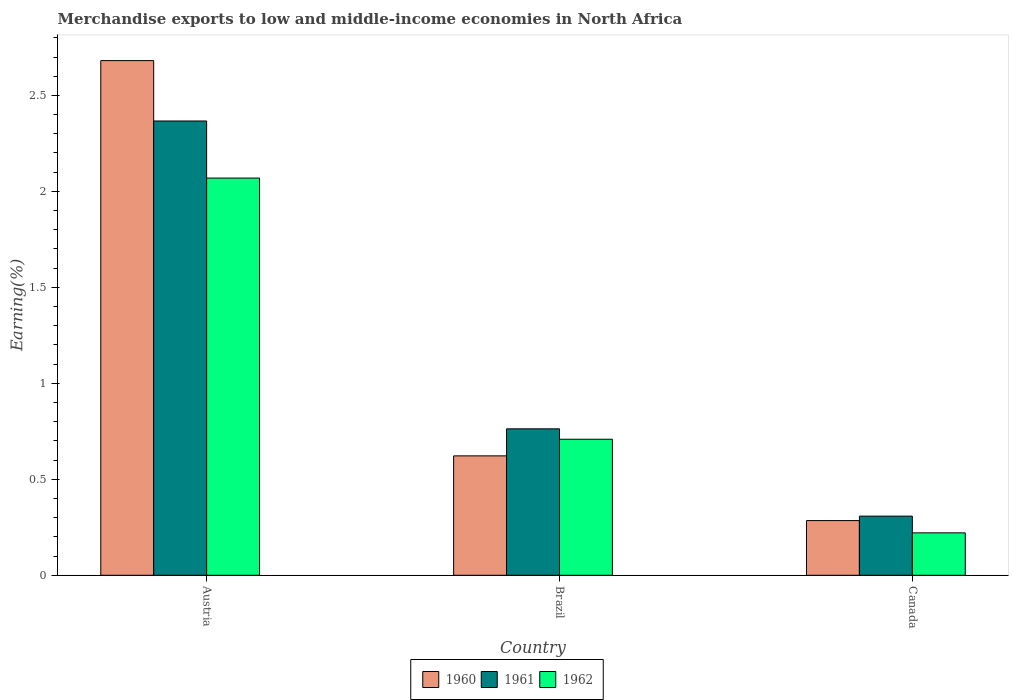How many different coloured bars are there?
Ensure brevity in your answer.  3. Are the number of bars per tick equal to the number of legend labels?
Provide a short and direct response. Yes. How many bars are there on the 2nd tick from the left?
Offer a terse response. 3. What is the percentage of amount earned from merchandise exports in 1961 in Brazil?
Make the answer very short. 0.76. Across all countries, what is the maximum percentage of amount earned from merchandise exports in 1962?
Your response must be concise. 2.07. Across all countries, what is the minimum percentage of amount earned from merchandise exports in 1962?
Offer a terse response. 0.22. In which country was the percentage of amount earned from merchandise exports in 1960 maximum?
Make the answer very short. Austria. What is the total percentage of amount earned from merchandise exports in 1962 in the graph?
Your answer should be compact. 3. What is the difference between the percentage of amount earned from merchandise exports in 1960 in Brazil and that in Canada?
Your response must be concise. 0.34. What is the difference between the percentage of amount earned from merchandise exports in 1962 in Canada and the percentage of amount earned from merchandise exports in 1961 in Austria?
Make the answer very short. -2.15. What is the average percentage of amount earned from merchandise exports in 1962 per country?
Provide a succinct answer. 1. What is the difference between the percentage of amount earned from merchandise exports of/in 1962 and percentage of amount earned from merchandise exports of/in 1960 in Brazil?
Offer a terse response. 0.09. In how many countries, is the percentage of amount earned from merchandise exports in 1962 greater than 0.4 %?
Keep it short and to the point. 2. What is the ratio of the percentage of amount earned from merchandise exports in 1961 in Austria to that in Canada?
Provide a short and direct response. 7.68. Is the difference between the percentage of amount earned from merchandise exports in 1962 in Austria and Brazil greater than the difference between the percentage of amount earned from merchandise exports in 1960 in Austria and Brazil?
Provide a short and direct response. No. What is the difference between the highest and the second highest percentage of amount earned from merchandise exports in 1960?
Provide a short and direct response. -2.06. What is the difference between the highest and the lowest percentage of amount earned from merchandise exports in 1961?
Your response must be concise. 2.06. In how many countries, is the percentage of amount earned from merchandise exports in 1960 greater than the average percentage of amount earned from merchandise exports in 1960 taken over all countries?
Your response must be concise. 1. What does the 3rd bar from the right in Canada represents?
Offer a very short reply. 1960. Is it the case that in every country, the sum of the percentage of amount earned from merchandise exports in 1962 and percentage of amount earned from merchandise exports in 1960 is greater than the percentage of amount earned from merchandise exports in 1961?
Offer a very short reply. Yes. Are all the bars in the graph horizontal?
Ensure brevity in your answer.  No. Are the values on the major ticks of Y-axis written in scientific E-notation?
Your response must be concise. No. Does the graph contain any zero values?
Provide a succinct answer. No. Does the graph contain grids?
Keep it short and to the point. No. What is the title of the graph?
Give a very brief answer. Merchandise exports to low and middle-income economies in North Africa. What is the label or title of the X-axis?
Give a very brief answer. Country. What is the label or title of the Y-axis?
Provide a succinct answer. Earning(%). What is the Earning(%) of 1960 in Austria?
Your answer should be compact. 2.68. What is the Earning(%) in 1961 in Austria?
Your response must be concise. 2.37. What is the Earning(%) of 1962 in Austria?
Your answer should be compact. 2.07. What is the Earning(%) in 1960 in Brazil?
Provide a short and direct response. 0.62. What is the Earning(%) of 1961 in Brazil?
Your answer should be very brief. 0.76. What is the Earning(%) of 1962 in Brazil?
Make the answer very short. 0.71. What is the Earning(%) in 1960 in Canada?
Provide a short and direct response. 0.28. What is the Earning(%) in 1961 in Canada?
Give a very brief answer. 0.31. What is the Earning(%) of 1962 in Canada?
Offer a very short reply. 0.22. Across all countries, what is the maximum Earning(%) in 1960?
Give a very brief answer. 2.68. Across all countries, what is the maximum Earning(%) in 1961?
Give a very brief answer. 2.37. Across all countries, what is the maximum Earning(%) in 1962?
Ensure brevity in your answer.  2.07. Across all countries, what is the minimum Earning(%) of 1960?
Your response must be concise. 0.28. Across all countries, what is the minimum Earning(%) in 1961?
Make the answer very short. 0.31. Across all countries, what is the minimum Earning(%) in 1962?
Make the answer very short. 0.22. What is the total Earning(%) of 1960 in the graph?
Make the answer very short. 3.59. What is the total Earning(%) in 1961 in the graph?
Offer a very short reply. 3.44. What is the total Earning(%) of 1962 in the graph?
Provide a short and direct response. 3. What is the difference between the Earning(%) of 1960 in Austria and that in Brazil?
Your answer should be very brief. 2.06. What is the difference between the Earning(%) of 1961 in Austria and that in Brazil?
Offer a terse response. 1.6. What is the difference between the Earning(%) in 1962 in Austria and that in Brazil?
Your answer should be compact. 1.36. What is the difference between the Earning(%) of 1960 in Austria and that in Canada?
Your response must be concise. 2.4. What is the difference between the Earning(%) in 1961 in Austria and that in Canada?
Provide a succinct answer. 2.06. What is the difference between the Earning(%) in 1962 in Austria and that in Canada?
Offer a terse response. 1.85. What is the difference between the Earning(%) in 1960 in Brazil and that in Canada?
Provide a short and direct response. 0.34. What is the difference between the Earning(%) of 1961 in Brazil and that in Canada?
Keep it short and to the point. 0.45. What is the difference between the Earning(%) of 1962 in Brazil and that in Canada?
Keep it short and to the point. 0.49. What is the difference between the Earning(%) of 1960 in Austria and the Earning(%) of 1961 in Brazil?
Provide a succinct answer. 1.92. What is the difference between the Earning(%) of 1960 in Austria and the Earning(%) of 1962 in Brazil?
Keep it short and to the point. 1.97. What is the difference between the Earning(%) in 1961 in Austria and the Earning(%) in 1962 in Brazil?
Ensure brevity in your answer.  1.66. What is the difference between the Earning(%) of 1960 in Austria and the Earning(%) of 1961 in Canada?
Make the answer very short. 2.37. What is the difference between the Earning(%) in 1960 in Austria and the Earning(%) in 1962 in Canada?
Give a very brief answer. 2.46. What is the difference between the Earning(%) in 1961 in Austria and the Earning(%) in 1962 in Canada?
Your answer should be compact. 2.15. What is the difference between the Earning(%) of 1960 in Brazil and the Earning(%) of 1961 in Canada?
Your answer should be compact. 0.31. What is the difference between the Earning(%) of 1960 in Brazil and the Earning(%) of 1962 in Canada?
Provide a succinct answer. 0.4. What is the difference between the Earning(%) in 1961 in Brazil and the Earning(%) in 1962 in Canada?
Your answer should be compact. 0.54. What is the average Earning(%) in 1960 per country?
Your answer should be compact. 1.2. What is the average Earning(%) in 1961 per country?
Make the answer very short. 1.15. What is the average Earning(%) in 1962 per country?
Provide a succinct answer. 1. What is the difference between the Earning(%) in 1960 and Earning(%) in 1961 in Austria?
Provide a short and direct response. 0.31. What is the difference between the Earning(%) of 1960 and Earning(%) of 1962 in Austria?
Your answer should be compact. 0.61. What is the difference between the Earning(%) of 1961 and Earning(%) of 1962 in Austria?
Your response must be concise. 0.3. What is the difference between the Earning(%) in 1960 and Earning(%) in 1961 in Brazil?
Keep it short and to the point. -0.14. What is the difference between the Earning(%) in 1960 and Earning(%) in 1962 in Brazil?
Offer a terse response. -0.09. What is the difference between the Earning(%) of 1961 and Earning(%) of 1962 in Brazil?
Your answer should be very brief. 0.05. What is the difference between the Earning(%) of 1960 and Earning(%) of 1961 in Canada?
Offer a terse response. -0.02. What is the difference between the Earning(%) of 1960 and Earning(%) of 1962 in Canada?
Your answer should be very brief. 0.06. What is the difference between the Earning(%) of 1961 and Earning(%) of 1962 in Canada?
Give a very brief answer. 0.09. What is the ratio of the Earning(%) in 1960 in Austria to that in Brazil?
Your response must be concise. 4.31. What is the ratio of the Earning(%) of 1961 in Austria to that in Brazil?
Your answer should be very brief. 3.1. What is the ratio of the Earning(%) of 1962 in Austria to that in Brazil?
Your response must be concise. 2.92. What is the ratio of the Earning(%) in 1960 in Austria to that in Canada?
Your answer should be compact. 9.41. What is the ratio of the Earning(%) in 1961 in Austria to that in Canada?
Give a very brief answer. 7.68. What is the ratio of the Earning(%) in 1962 in Austria to that in Canada?
Your answer should be compact. 9.36. What is the ratio of the Earning(%) of 1960 in Brazil to that in Canada?
Give a very brief answer. 2.18. What is the ratio of the Earning(%) in 1961 in Brazil to that in Canada?
Ensure brevity in your answer.  2.48. What is the ratio of the Earning(%) in 1962 in Brazil to that in Canada?
Your response must be concise. 3.21. What is the difference between the highest and the second highest Earning(%) of 1960?
Provide a short and direct response. 2.06. What is the difference between the highest and the second highest Earning(%) of 1961?
Provide a succinct answer. 1.6. What is the difference between the highest and the second highest Earning(%) of 1962?
Your answer should be very brief. 1.36. What is the difference between the highest and the lowest Earning(%) of 1960?
Give a very brief answer. 2.4. What is the difference between the highest and the lowest Earning(%) of 1961?
Offer a terse response. 2.06. What is the difference between the highest and the lowest Earning(%) in 1962?
Your response must be concise. 1.85. 